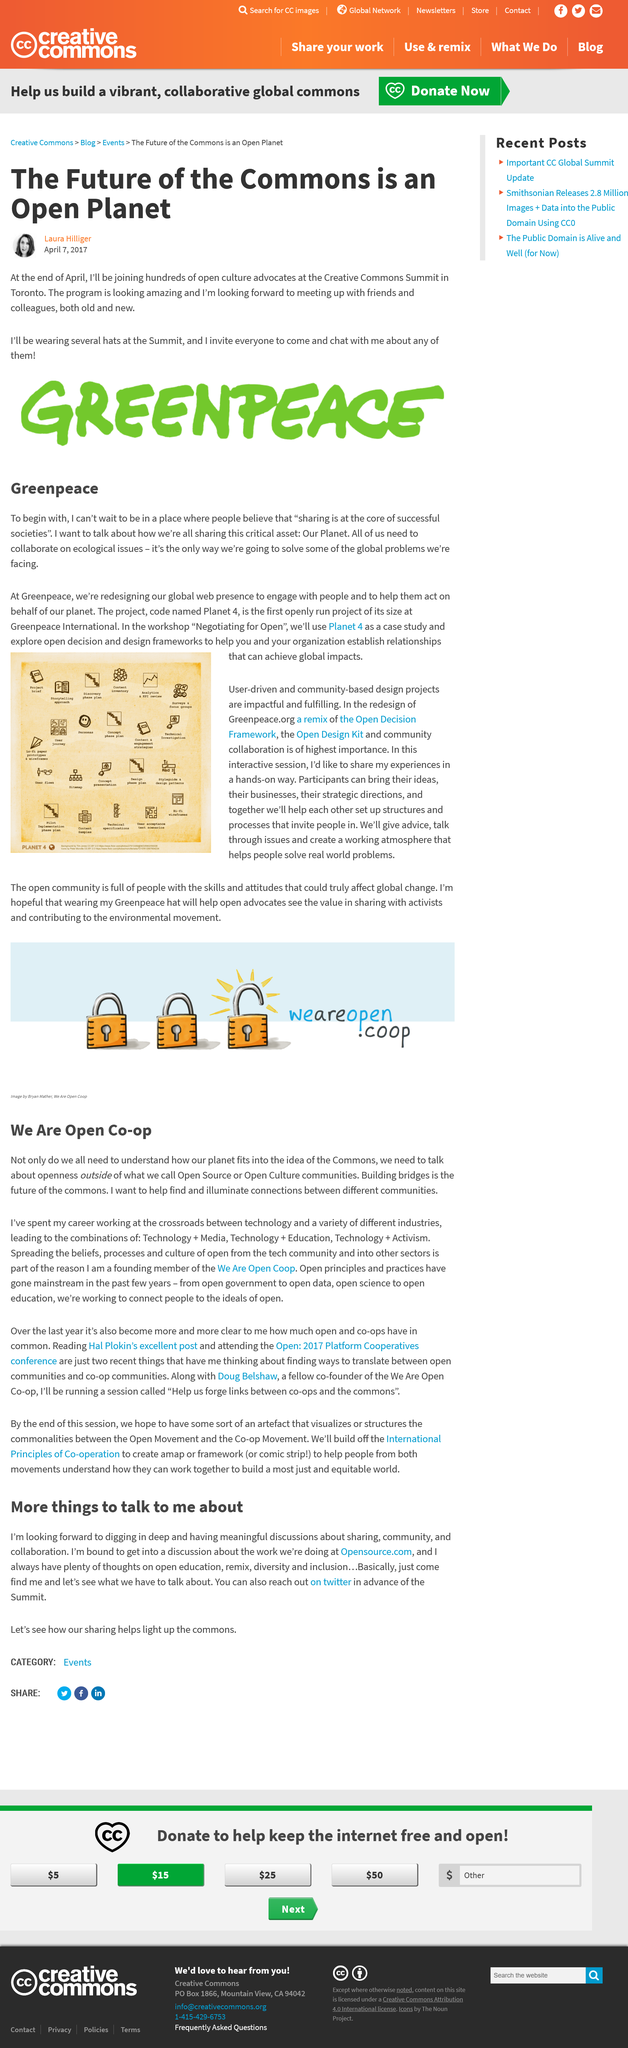List a handful of essential elements in this visual. At the end of April, Laura Hilliger will join the open culture advocates. The future of the commons is thought to be building bridges. One of the founding members of We Are Open Co-op, during their career, worked at the intersection of technology and various industries, contributing to the development of cutting-edge technology. We Are Open Co-op's founding member aims to uncover and highlight the connections between various communities to aid in the organization's success. Laura Hilliger is excited to share her thoughts on how we are all sharing our planet at the summit. 